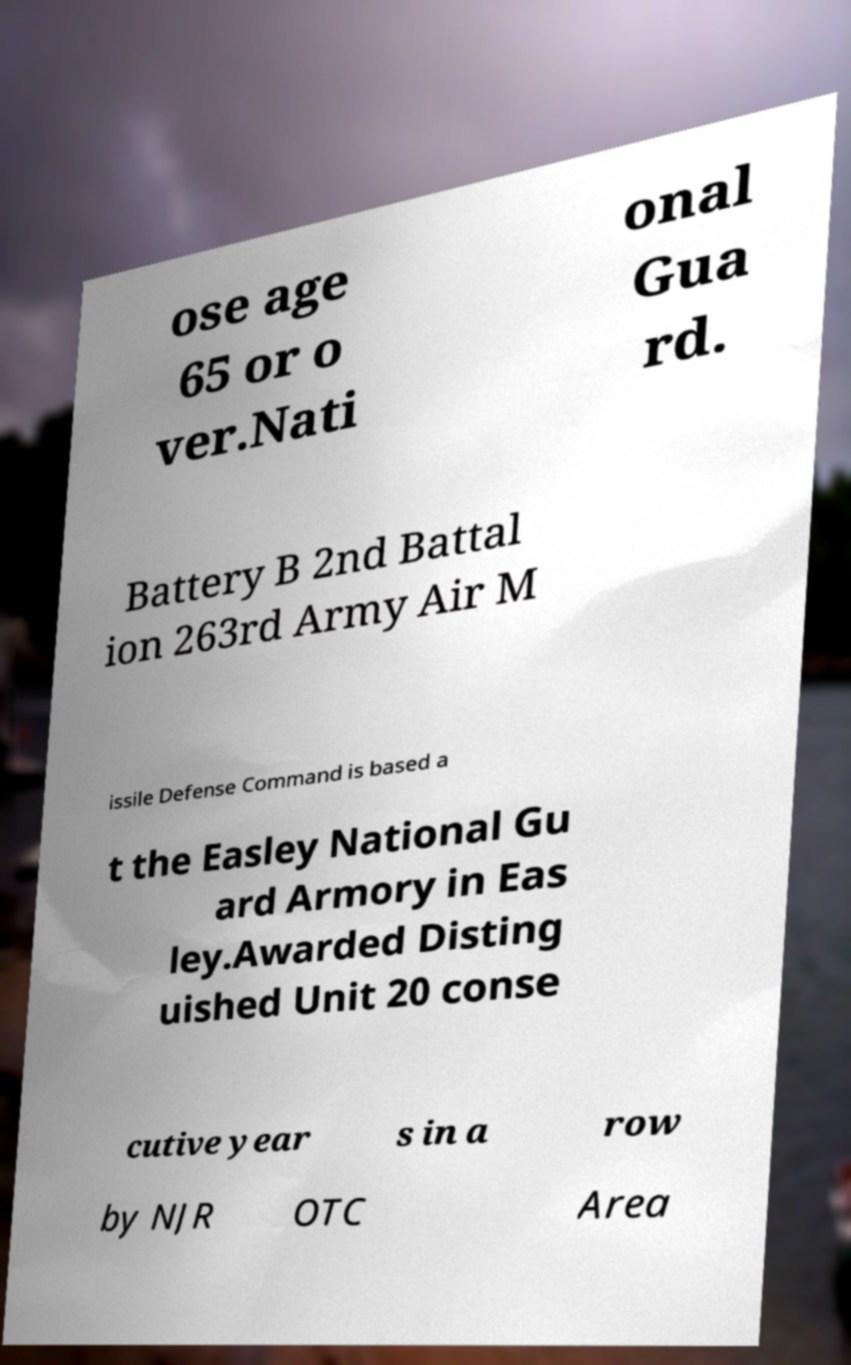Please read and relay the text visible in this image. What does it say? ose age 65 or o ver.Nati onal Gua rd. Battery B 2nd Battal ion 263rd Army Air M issile Defense Command is based a t the Easley National Gu ard Armory in Eas ley.Awarded Disting uished Unit 20 conse cutive year s in a row by NJR OTC Area 